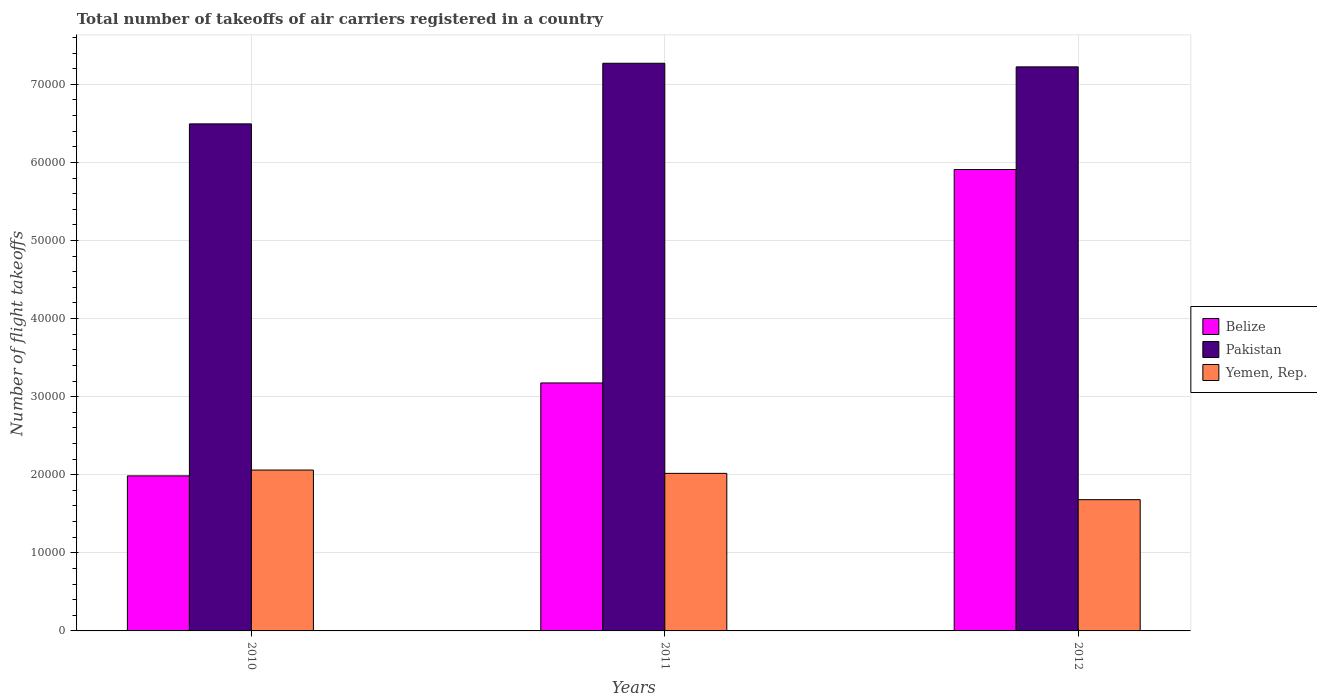Are the number of bars per tick equal to the number of legend labels?
Keep it short and to the point. Yes. Are the number of bars on each tick of the X-axis equal?
Provide a short and direct response. Yes. What is the label of the 3rd group of bars from the left?
Make the answer very short. 2012. What is the total number of flight takeoffs in Belize in 2012?
Provide a succinct answer. 5.91e+04. Across all years, what is the maximum total number of flight takeoffs in Pakistan?
Offer a terse response. 7.27e+04. Across all years, what is the minimum total number of flight takeoffs in Yemen, Rep.?
Ensure brevity in your answer.  1.68e+04. In which year was the total number of flight takeoffs in Belize maximum?
Your answer should be compact. 2012. In which year was the total number of flight takeoffs in Belize minimum?
Ensure brevity in your answer.  2010. What is the total total number of flight takeoffs in Yemen, Rep. in the graph?
Keep it short and to the point. 5.76e+04. What is the difference between the total number of flight takeoffs in Yemen, Rep. in 2010 and that in 2011?
Provide a short and direct response. 423.27. What is the difference between the total number of flight takeoffs in Pakistan in 2010 and the total number of flight takeoffs in Belize in 2012?
Keep it short and to the point. 5843. What is the average total number of flight takeoffs in Yemen, Rep. per year?
Provide a succinct answer. 1.92e+04. In the year 2011, what is the difference between the total number of flight takeoffs in Yemen, Rep. and total number of flight takeoffs in Pakistan?
Offer a terse response. -5.25e+04. In how many years, is the total number of flight takeoffs in Belize greater than 58000?
Provide a succinct answer. 1. What is the ratio of the total number of flight takeoffs in Pakistan in 2010 to that in 2011?
Give a very brief answer. 0.89. What is the difference between the highest and the second highest total number of flight takeoffs in Yemen, Rep.?
Your answer should be compact. 423.27. What is the difference between the highest and the lowest total number of flight takeoffs in Yemen, Rep.?
Ensure brevity in your answer.  3792.59. In how many years, is the total number of flight takeoffs in Pakistan greater than the average total number of flight takeoffs in Pakistan taken over all years?
Your answer should be compact. 2. What does the 2nd bar from the right in 2011 represents?
Provide a succinct answer. Pakistan. How many bars are there?
Your response must be concise. 9. Are all the bars in the graph horizontal?
Offer a very short reply. No. How many years are there in the graph?
Keep it short and to the point. 3. What is the difference between two consecutive major ticks on the Y-axis?
Keep it short and to the point. 10000. Does the graph contain any zero values?
Your response must be concise. No. Does the graph contain grids?
Keep it short and to the point. Yes. How many legend labels are there?
Offer a terse response. 3. How are the legend labels stacked?
Your answer should be compact. Vertical. What is the title of the graph?
Give a very brief answer. Total number of takeoffs of air carriers registered in a country. Does "Mauritania" appear as one of the legend labels in the graph?
Provide a short and direct response. No. What is the label or title of the X-axis?
Offer a very short reply. Years. What is the label or title of the Y-axis?
Offer a terse response. Number of flight takeoffs. What is the Number of flight takeoffs in Belize in 2010?
Your answer should be very brief. 1.99e+04. What is the Number of flight takeoffs in Pakistan in 2010?
Keep it short and to the point. 6.49e+04. What is the Number of flight takeoffs of Yemen, Rep. in 2010?
Make the answer very short. 2.06e+04. What is the Number of flight takeoffs in Belize in 2011?
Your response must be concise. 3.18e+04. What is the Number of flight takeoffs in Pakistan in 2011?
Provide a succinct answer. 7.27e+04. What is the Number of flight takeoffs in Yemen, Rep. in 2011?
Your answer should be very brief. 2.02e+04. What is the Number of flight takeoffs of Belize in 2012?
Give a very brief answer. 5.91e+04. What is the Number of flight takeoffs in Pakistan in 2012?
Your answer should be very brief. 7.22e+04. What is the Number of flight takeoffs in Yemen, Rep. in 2012?
Make the answer very short. 1.68e+04. Across all years, what is the maximum Number of flight takeoffs of Belize?
Your answer should be compact. 5.91e+04. Across all years, what is the maximum Number of flight takeoffs of Pakistan?
Your answer should be very brief. 7.27e+04. Across all years, what is the maximum Number of flight takeoffs in Yemen, Rep.?
Give a very brief answer. 2.06e+04. Across all years, what is the minimum Number of flight takeoffs of Belize?
Keep it short and to the point. 1.99e+04. Across all years, what is the minimum Number of flight takeoffs in Pakistan?
Provide a succinct answer. 6.49e+04. Across all years, what is the minimum Number of flight takeoffs in Yemen, Rep.?
Provide a short and direct response. 1.68e+04. What is the total Number of flight takeoffs of Belize in the graph?
Ensure brevity in your answer.  1.11e+05. What is the total Number of flight takeoffs of Pakistan in the graph?
Offer a very short reply. 2.10e+05. What is the total Number of flight takeoffs in Yemen, Rep. in the graph?
Make the answer very short. 5.76e+04. What is the difference between the Number of flight takeoffs of Belize in 2010 and that in 2011?
Your answer should be compact. -1.19e+04. What is the difference between the Number of flight takeoffs in Pakistan in 2010 and that in 2011?
Your answer should be compact. -7763. What is the difference between the Number of flight takeoffs of Yemen, Rep. in 2010 and that in 2011?
Make the answer very short. 423.27. What is the difference between the Number of flight takeoffs of Belize in 2010 and that in 2012?
Your answer should be very brief. -3.92e+04. What is the difference between the Number of flight takeoffs in Pakistan in 2010 and that in 2012?
Offer a very short reply. -7300. What is the difference between the Number of flight takeoffs in Yemen, Rep. in 2010 and that in 2012?
Offer a terse response. 3792.59. What is the difference between the Number of flight takeoffs in Belize in 2011 and that in 2012?
Your answer should be compact. -2.73e+04. What is the difference between the Number of flight takeoffs in Pakistan in 2011 and that in 2012?
Provide a succinct answer. 463. What is the difference between the Number of flight takeoffs of Yemen, Rep. in 2011 and that in 2012?
Your response must be concise. 3369.32. What is the difference between the Number of flight takeoffs in Belize in 2010 and the Number of flight takeoffs in Pakistan in 2011?
Your answer should be very brief. -5.28e+04. What is the difference between the Number of flight takeoffs in Belize in 2010 and the Number of flight takeoffs in Yemen, Rep. in 2011?
Keep it short and to the point. -321.73. What is the difference between the Number of flight takeoffs of Pakistan in 2010 and the Number of flight takeoffs of Yemen, Rep. in 2011?
Your answer should be very brief. 4.48e+04. What is the difference between the Number of flight takeoffs in Belize in 2010 and the Number of flight takeoffs in Pakistan in 2012?
Offer a very short reply. -5.24e+04. What is the difference between the Number of flight takeoffs in Belize in 2010 and the Number of flight takeoffs in Yemen, Rep. in 2012?
Keep it short and to the point. 3047.59. What is the difference between the Number of flight takeoffs of Pakistan in 2010 and the Number of flight takeoffs of Yemen, Rep. in 2012?
Ensure brevity in your answer.  4.81e+04. What is the difference between the Number of flight takeoffs of Belize in 2011 and the Number of flight takeoffs of Pakistan in 2012?
Your answer should be very brief. -4.05e+04. What is the difference between the Number of flight takeoffs in Belize in 2011 and the Number of flight takeoffs in Yemen, Rep. in 2012?
Your answer should be compact. 1.49e+04. What is the difference between the Number of flight takeoffs in Pakistan in 2011 and the Number of flight takeoffs in Yemen, Rep. in 2012?
Your answer should be very brief. 5.59e+04. What is the average Number of flight takeoffs in Belize per year?
Offer a terse response. 3.69e+04. What is the average Number of flight takeoffs of Pakistan per year?
Provide a succinct answer. 7.00e+04. What is the average Number of flight takeoffs in Yemen, Rep. per year?
Provide a short and direct response. 1.92e+04. In the year 2010, what is the difference between the Number of flight takeoffs of Belize and Number of flight takeoffs of Pakistan?
Provide a short and direct response. -4.51e+04. In the year 2010, what is the difference between the Number of flight takeoffs in Belize and Number of flight takeoffs in Yemen, Rep.?
Give a very brief answer. -745. In the year 2010, what is the difference between the Number of flight takeoffs in Pakistan and Number of flight takeoffs in Yemen, Rep.?
Your response must be concise. 4.43e+04. In the year 2011, what is the difference between the Number of flight takeoffs of Belize and Number of flight takeoffs of Pakistan?
Make the answer very short. -4.09e+04. In the year 2011, what is the difference between the Number of flight takeoffs of Belize and Number of flight takeoffs of Yemen, Rep.?
Provide a succinct answer. 1.16e+04. In the year 2011, what is the difference between the Number of flight takeoffs in Pakistan and Number of flight takeoffs in Yemen, Rep.?
Your answer should be very brief. 5.25e+04. In the year 2012, what is the difference between the Number of flight takeoffs of Belize and Number of flight takeoffs of Pakistan?
Keep it short and to the point. -1.31e+04. In the year 2012, what is the difference between the Number of flight takeoffs of Belize and Number of flight takeoffs of Yemen, Rep.?
Your response must be concise. 4.23e+04. In the year 2012, what is the difference between the Number of flight takeoffs in Pakistan and Number of flight takeoffs in Yemen, Rep.?
Ensure brevity in your answer.  5.54e+04. What is the ratio of the Number of flight takeoffs in Belize in 2010 to that in 2011?
Your answer should be compact. 0.63. What is the ratio of the Number of flight takeoffs in Pakistan in 2010 to that in 2011?
Give a very brief answer. 0.89. What is the ratio of the Number of flight takeoffs of Belize in 2010 to that in 2012?
Make the answer very short. 0.34. What is the ratio of the Number of flight takeoffs in Pakistan in 2010 to that in 2012?
Offer a very short reply. 0.9. What is the ratio of the Number of flight takeoffs of Yemen, Rep. in 2010 to that in 2012?
Your response must be concise. 1.23. What is the ratio of the Number of flight takeoffs of Belize in 2011 to that in 2012?
Offer a terse response. 0.54. What is the ratio of the Number of flight takeoffs of Pakistan in 2011 to that in 2012?
Your answer should be compact. 1.01. What is the ratio of the Number of flight takeoffs in Yemen, Rep. in 2011 to that in 2012?
Your response must be concise. 1.2. What is the difference between the highest and the second highest Number of flight takeoffs in Belize?
Ensure brevity in your answer.  2.73e+04. What is the difference between the highest and the second highest Number of flight takeoffs of Pakistan?
Ensure brevity in your answer.  463. What is the difference between the highest and the second highest Number of flight takeoffs of Yemen, Rep.?
Give a very brief answer. 423.27. What is the difference between the highest and the lowest Number of flight takeoffs of Belize?
Your answer should be compact. 3.92e+04. What is the difference between the highest and the lowest Number of flight takeoffs of Pakistan?
Give a very brief answer. 7763. What is the difference between the highest and the lowest Number of flight takeoffs of Yemen, Rep.?
Ensure brevity in your answer.  3792.59. 